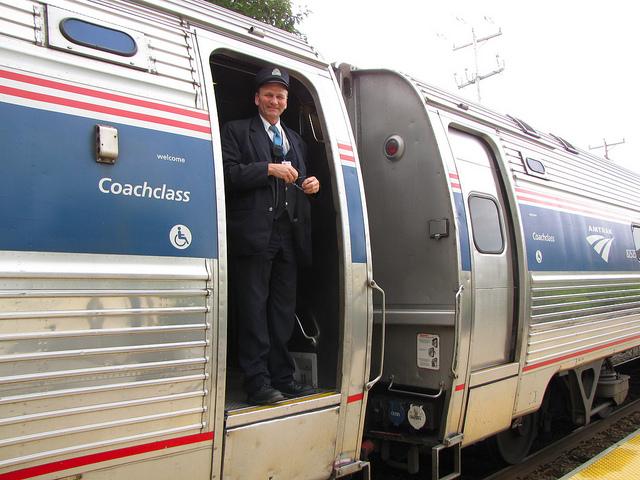Does this man work on the train?
Be succinct. Yes. Did any people board the train?
Quick response, please. Yes. What is the train resting on?
Quick response, please. Tracks. 